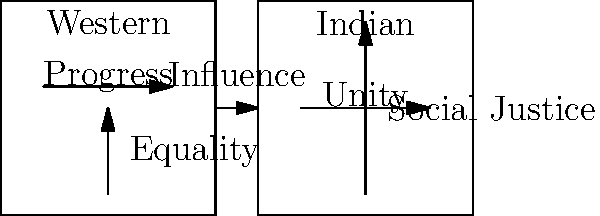Analyze the symbolism in this political cartoon comparing Western and Indian leftist ideologies. How do the visual elements represent the similarities and differences between these two perspectives, and what does this suggest about the intersection of Indian and Western leftist thought? 1. Western leftist symbolism:
   - Horizontal arrow labeled "Progress": Represents the focus on forward movement and societal advancement.
   - Vertical arrow labeled "Equality": Signifies the emphasis on social and economic equality.

2. Indian leftist symbolism:
   - Horizontal arrow labeled "Unity": Represents the importance of social cohesion and collective action.
   - Vertical arrow labeled "Social Justice": Indicates a strong focus on addressing societal inequalities.

3. Comparison of symbols:
   - Both ideologies use vertical arrows, suggesting a shared concern for hierarchical societal issues.
   - The Western ideology emphasizes "Progress," while the Indian focuses on "Unity," highlighting different priorities.

4. Connecting arrow:
   - The arrow labeled "Influence" between the two cartoons suggests a flow of ideas from Western to Indian leftist thought.

5. Intersection analysis:
   - The shared use of vertical arrows (Equality/Social Justice) indicates a common concern for societal inequalities.
   - The differences in horizontal concepts (Progress/Unity) suggest distinct cultural emphases within leftist ideologies.

6. Implications:
   - The cartoon suggests that while Indian leftist thought has been influenced by Western ideas, it has developed its own unique focus on unity and social justice.
   - The intersection of these ideologies appears to be primarily in their shared concern for addressing societal inequalities, albeit with different approaches.
Answer: The cartoon illustrates shared concerns for equality and social justice between Western and Indian leftist ideologies, while highlighting distinct cultural emphases on progress versus unity, suggesting a nuanced intersection of thought with common goals but culturally-specific approaches. 